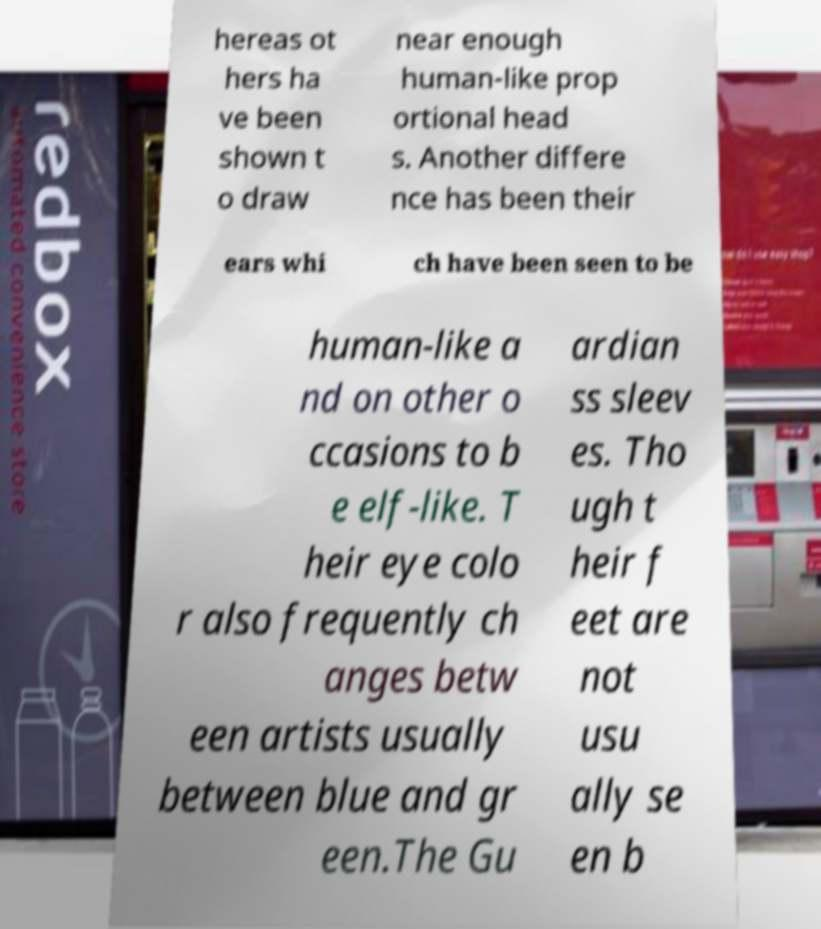I need the written content from this picture converted into text. Can you do that? hereas ot hers ha ve been shown t o draw near enough human-like prop ortional head s. Another differe nce has been their ears whi ch have been seen to be human-like a nd on other o ccasions to b e elf-like. T heir eye colo r also frequently ch anges betw een artists usually between blue and gr een.The Gu ardian ss sleev es. Tho ugh t heir f eet are not usu ally se en b 